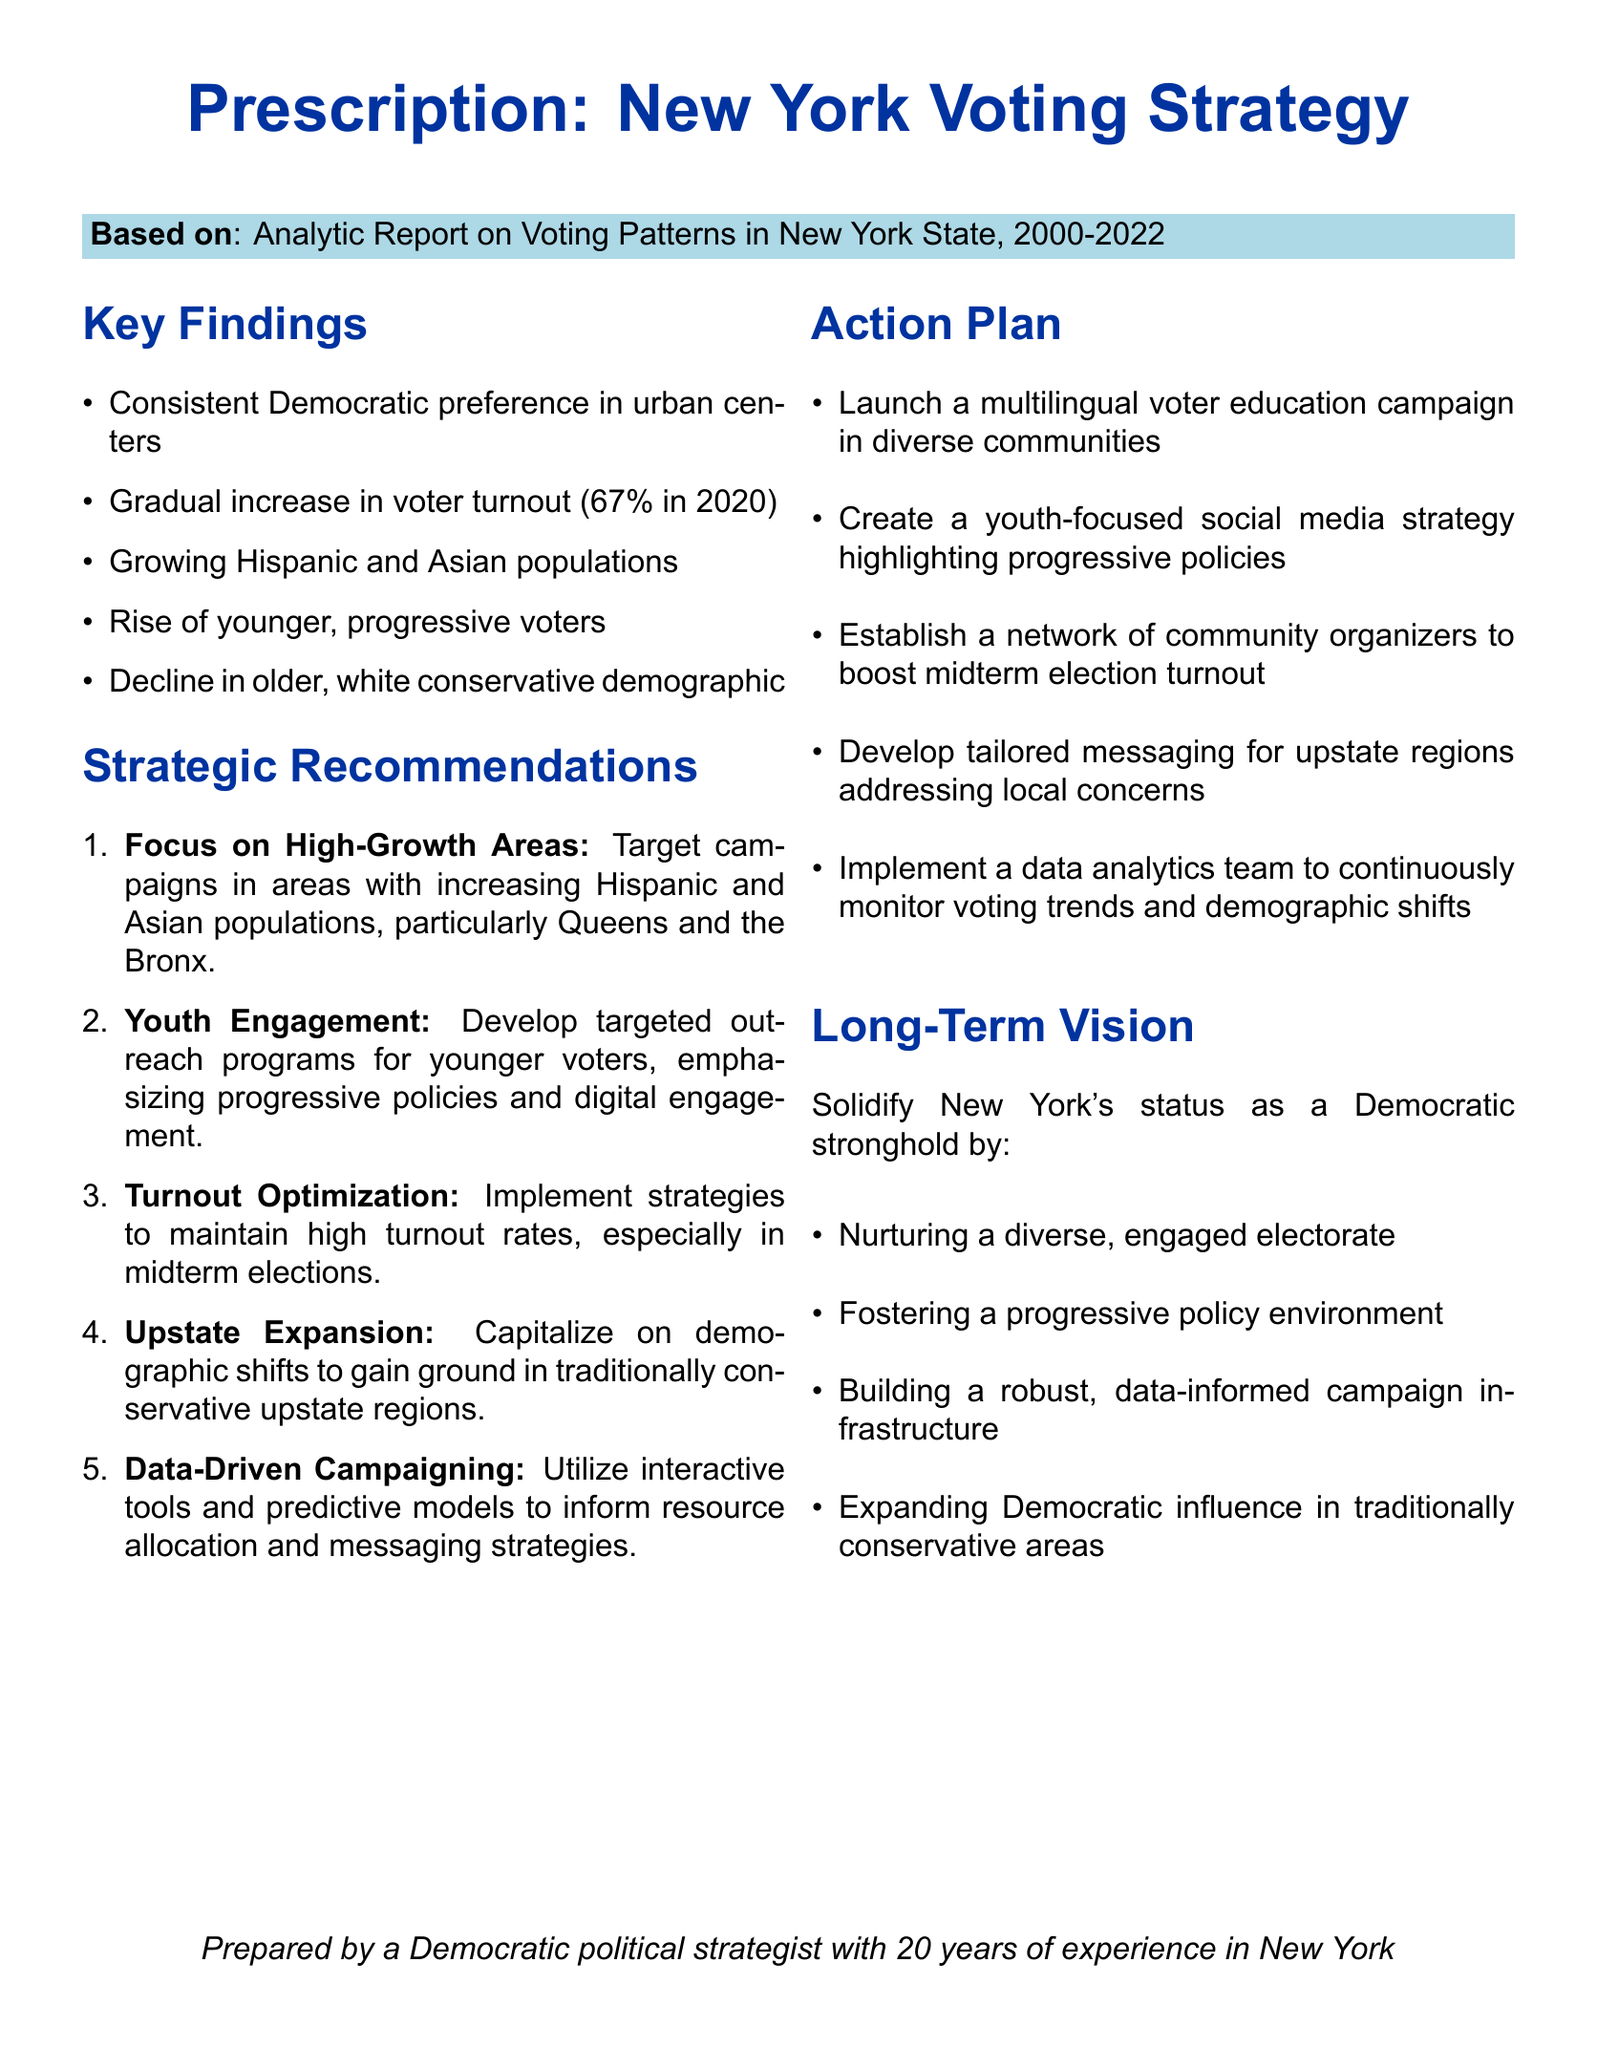what was the voter turnout in 2020? The document states that the voter turnout was 67% in 2020.
Answer: 67% which demographic is experiencing a decline? The document notes a decline in the older, white conservative demographic.
Answer: older, white conservative what is the color associated with the Democratic preference in urban centers? The document uses the color democratblue, which represents the Democratic preference.
Answer: democratblue what is the first strategic recommendation? The first recommendation is to focus on high-growth areas with increasing Hispanic and Asian populations.
Answer: Focus on High-Growth Areas how many recommendations are listed under strategic recommendations? The document enumerates five strategic recommendations for the campaign.
Answer: five what is the long-term vision for New York's status? The document mentions solidifying New York's status as a Democratic stronghold.
Answer: Democratic stronghold which borough is specifically mentioned for targeting campaigns? The document highlights Queens as a key area for targeting campaigns.
Answer: Queens what type of campaign is suggested for diverse communities? The document suggests launching a multilingual voter education campaign.
Answer: multilingual voter education campaign what is the goal of the youth-focused social media strategy? The goal is to highlight progressive policies to engage younger voters.
Answer: highlight progressive policies 